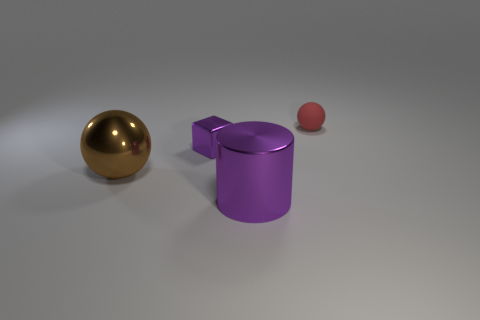There is a tiny red object; are there any tiny cubes behind it?
Ensure brevity in your answer.  No. There is a small object on the left side of the tiny ball; does it have the same color as the sphere that is to the left of the red object?
Your answer should be very brief. No. Is there a large red shiny thing of the same shape as the tiny rubber object?
Offer a very short reply. No. How many other objects are the same color as the tiny metal object?
Your answer should be very brief. 1. There is a large object in front of the sphere that is in front of the sphere on the right side of the large cylinder; what color is it?
Offer a terse response. Purple. Is the number of red rubber spheres that are in front of the large purple metal object the same as the number of cylinders?
Ensure brevity in your answer.  No. Do the ball that is left of the red ball and the metal block have the same size?
Make the answer very short. No. What number of brown balls are there?
Give a very brief answer. 1. How many small objects are both on the right side of the large metal cylinder and on the left side of the big metallic cylinder?
Offer a terse response. 0. Are there any tiny green cubes that have the same material as the red thing?
Offer a very short reply. No. 